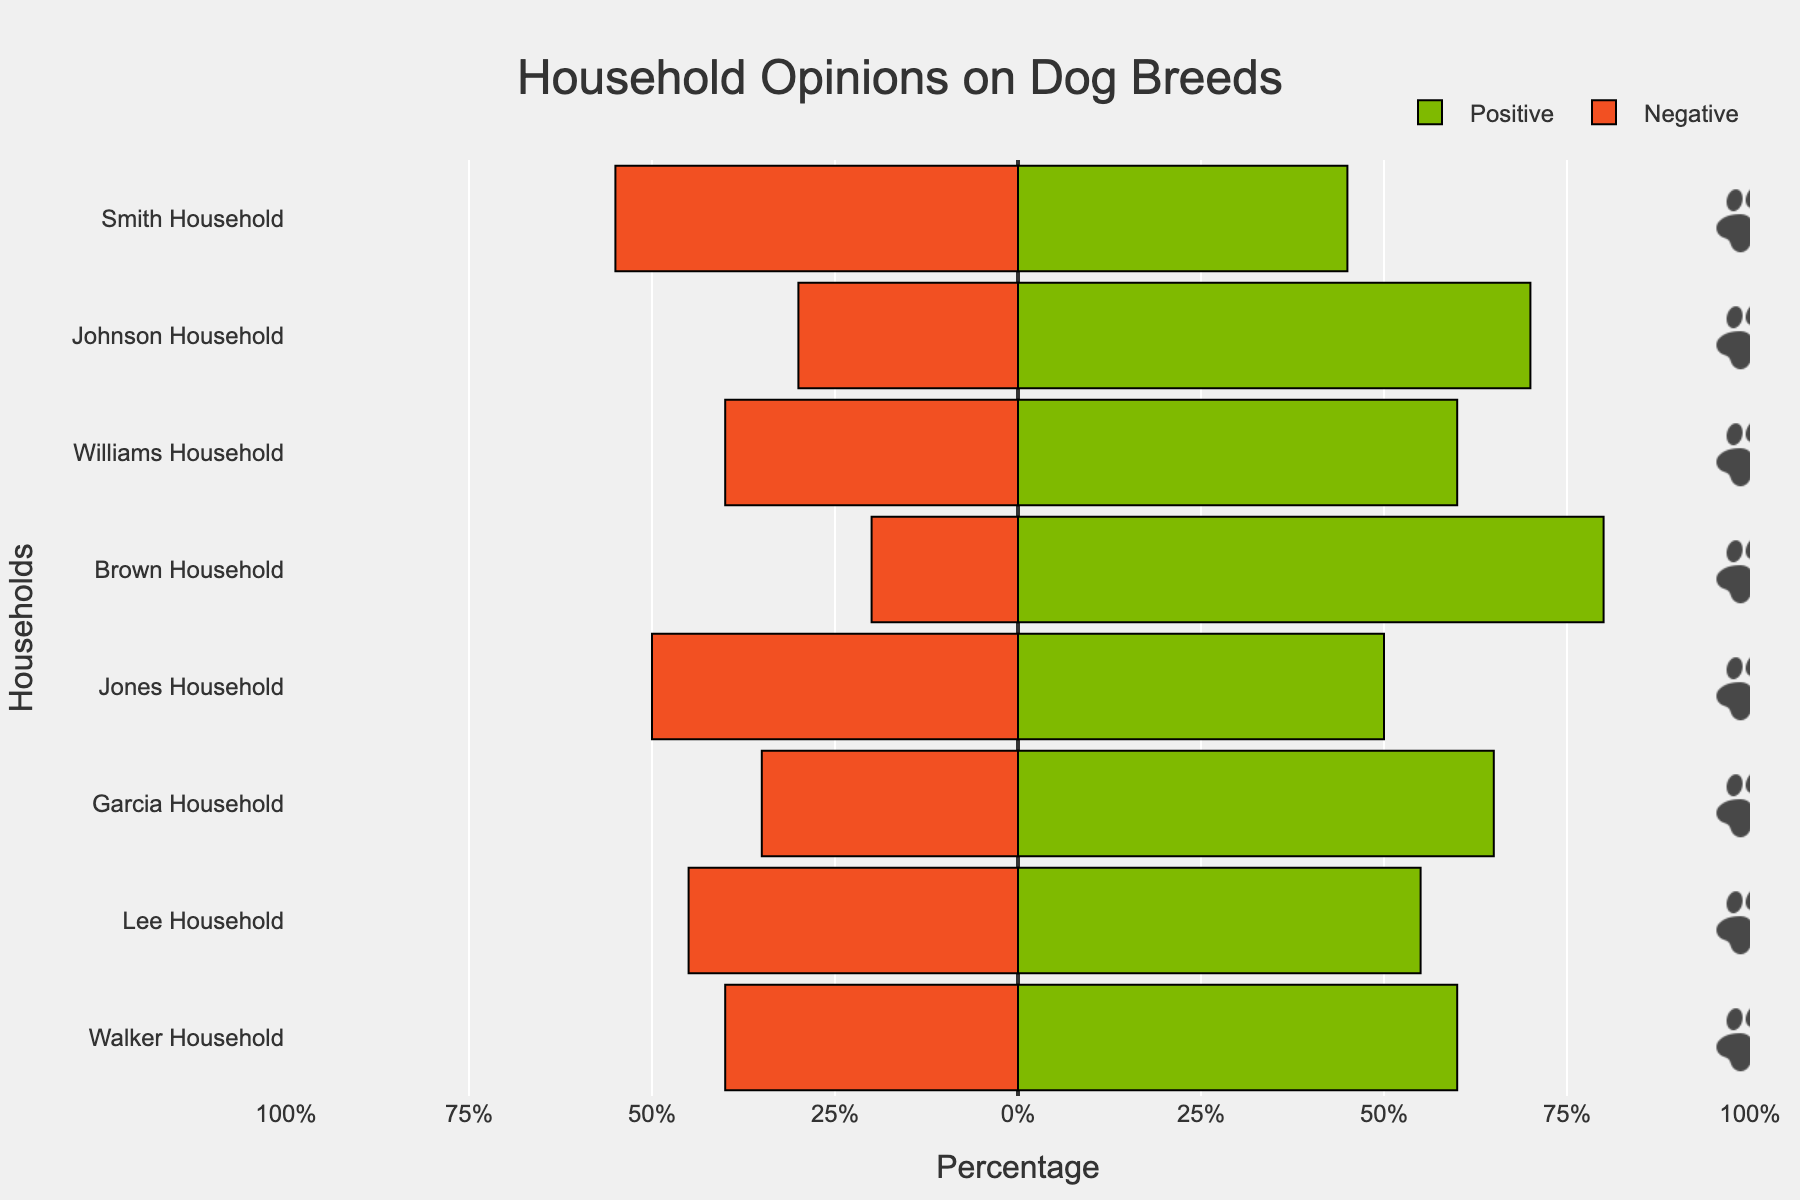What percentage of households have a positive opinion towards Golden Retrievers? Look at the bar representing the positive opinion for the Golden Retriever for the Brown Household. The length extends to 80% on the positive scale.
Answer: 80% Which household has the highest negative opinion and for which dog breed is it? Observe which bar extends the furthest to the left. The Smith Household has the highest negative opinion for Jack Russell Terrier, extending to 55%.
Answer: Smith Household, Jack Russell Terrier What is the difference in the percentage of positive opinions between the Johnson Household and the Lee Household? Subtract the percentage of positive opinions for the Lee Household (55%) from that of the Johnson Household (70%). 70% - 55% = 15%.
Answer: 15% In which households are the positive and negative opinions equal and for which dog breeds? Look for bars where the positive and negative opinions are of equal length. The Jones Household shows equal opinions for Poodles with both positive and negative bars extending to 50%.
Answer: Jones Household, Poodle Which breed has the highest overall positive opinion percentage across all households? Compare the length of positive opinion bars across all households. The Golden Retriever has the highest positive opinion percentage of 80% in the Brown Household.
Answer: Golden Retriever How much more positively does the Walker Household view Huskies compared to Beagles in the Williams Household? Look at the positive opinion bar for the Walker Household's Huskies (60%) and the Williams Household's Beagles (60%). They are the same.
Answer: 0% What is the percentage difference between the positive and negative opinions for Bulldogs in the Lee Household? Subtract the negative opinion percentage (45%) from the positive opinion percentage (55%) of the Lee Household. 55% - 45% = 10%.
Answer: 10% For the Smith Household, what is the combined percentage for opinions (positive and negative) toward Jack Russell Terriers? Add the positive (45%) and negative (55%) opinion percentages for Jack Russell Terriers in the Smith Household. 45% + 55% = 100%.
Answer: 100% How much higher is the positive opinion percentage for German Shepherds in the Garcia Household compared to the negative opinion percentage? Subtract the negative opinion percentage for German Shepherds in the Garcia Household (35%) from the positive opinion percentage (65%). 65% - 35% = 30%.
Answer: 30% Which household has the most balanced opinion (least difference between positive and negative opinions) and for which breed? Look for the smallest difference between positive and negative bars across all households. The Jones Household has an equal balance (0% difference) for Poodles.
Answer: Jones Household, Poodle 